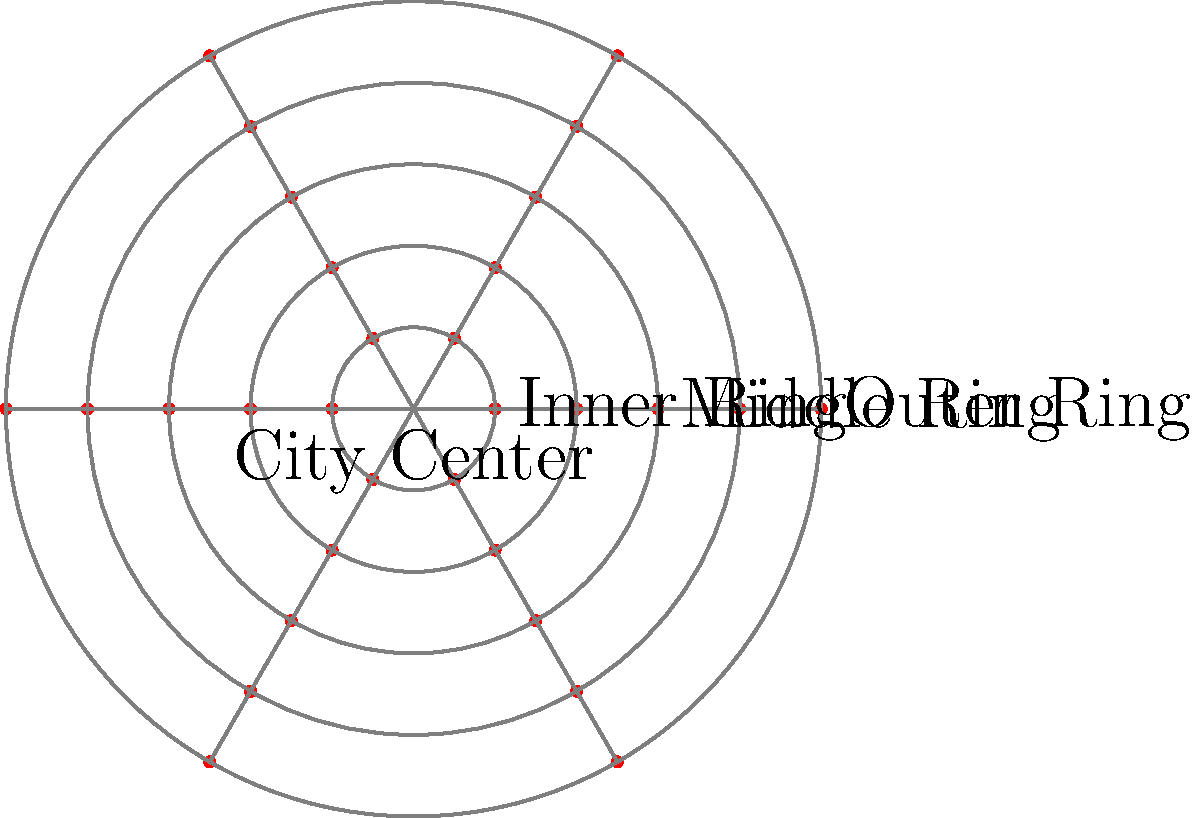Based on the polar coordinate representation of public sculpture distribution in a city, which ring road shows the highest concentration of sculptures, and what artistic movement might this pattern reflect? To answer this question, we need to analyze the polar coordinate graph and interpret its artistic implications:

1. The graph shows the distribution of public sculptures along three concentric ring roads: Inner, Middle, and Outer.

2. Each dot represents a sculpture, with more dots indicating a higher concentration.

3. Examining the rings:
   - Inner Ring (closest to the center): Has the highest density of dots.
   - Middle Ring: Has a moderate density of dots.
   - Outer Ring: Has the lowest density of dots.

4. The Inner Ring shows the highest concentration of sculptures, suggesting a focus on public art in the city center and historic districts.

5. This pattern often reflects the influence of the City Beautiful movement, which emerged in the late 19th and early 20th centuries. This movement emphasized the importance of beautifying city centers through public art and architecture.

6. The City Beautiful movement aimed to create grand, monumental urban spaces that would inspire civic pride and moral uplift. Concentrating sculptures in the city center aligns with these goals.

7. Additionally, this pattern might indicate the preservation of historical sculptures in older, central parts of the city, which often coincide with the inner ring road.

8. The decreasing density towards the outer rings could represent the expansion of the city over time, with newer areas having less established public art programs.
Answer: Inner Ring; City Beautiful movement 